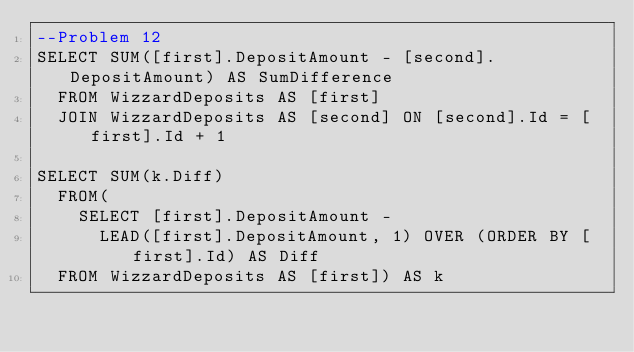Convert code to text. <code><loc_0><loc_0><loc_500><loc_500><_SQL_>--Problem 12
SELECT SUM([first].DepositAmount - [second].DepositAmount) AS SumDifference
	FROM WizzardDeposits AS [first]
	JOIN WizzardDeposits AS [second] ON [second].Id = [first].Id + 1

SELECT SUM(k.Diff)
	FROM(
		SELECT [first].DepositAmount -
			LEAD([first].DepositAmount, 1) OVER (ORDER BY [first].Id) AS Diff
	FROM WizzardDeposits AS [first]) AS k</code> 